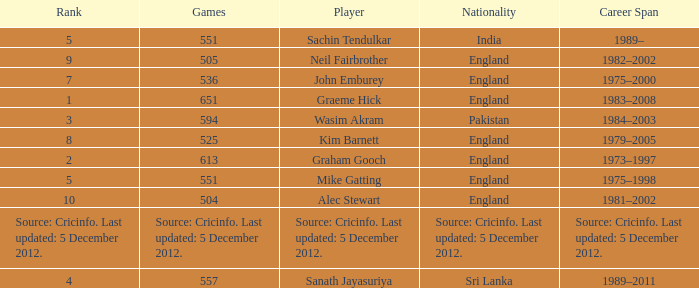What is graham gooch's citizenship? England. 